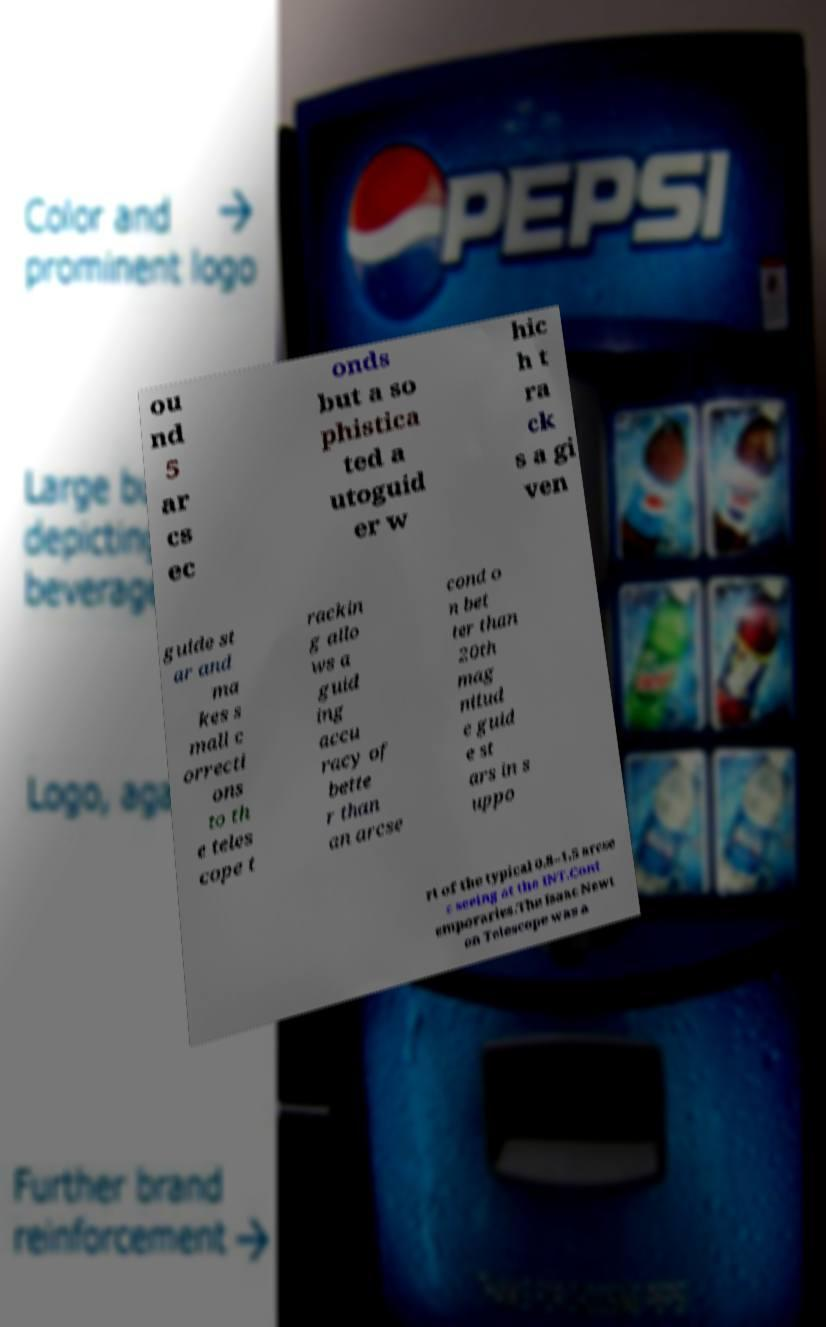Can you read and provide the text displayed in the image?This photo seems to have some interesting text. Can you extract and type it out for me? ou nd 5 ar cs ec onds but a so phistica ted a utoguid er w hic h t ra ck s a gi ven guide st ar and ma kes s mall c orrecti ons to th e teles cope t rackin g allo ws a guid ing accu racy of bette r than an arcse cond o n bet ter than 20th mag nitud e guid e st ars in s uppo rt of the typical 0.8–1.5 arcse c seeing at the INT.Cont emporaries.The Isaac Newt on Telescope was a 